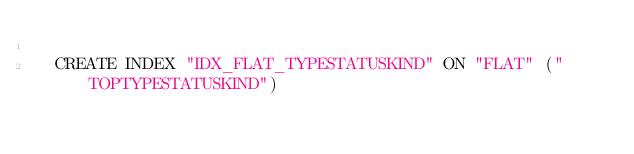<code> <loc_0><loc_0><loc_500><loc_500><_SQL_>
  CREATE INDEX "IDX_FLAT_TYPESTATUSKIND" ON "FLAT" ("TOPTYPESTATUSKIND") 
  </code> 